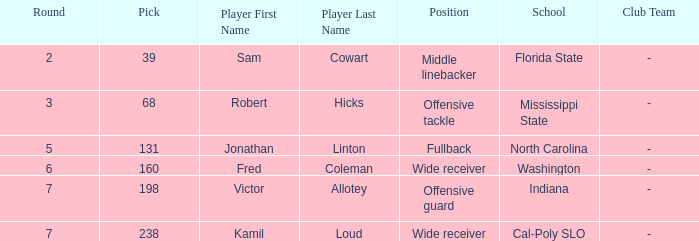Give me the full table as a dictionary. {'header': ['Round', 'Pick', 'Player First Name', 'Player Last Name', 'Position', 'School', 'Club Team'], 'rows': [['2', '39', 'Sam', 'Cowart', 'Middle linebacker', 'Florida State', '-'], ['3', '68', 'Robert', 'Hicks', 'Offensive tackle', 'Mississippi State', '-'], ['5', '131', 'Jonathan', 'Linton', 'Fullback', 'North Carolina', '-'], ['6', '160', 'Fred', 'Coleman', 'Wide receiver', 'Washington', '-'], ['7', '198', 'Victor', 'Allotey', 'Offensive guard', 'Indiana', '-'], ['7', '238', 'Kamil', 'Loud', 'Wide receiver', 'Cal-Poly SLO', '-']]} Which Round has a School/Club Team of north carolina, and a Pick larger than 131? 0.0. 